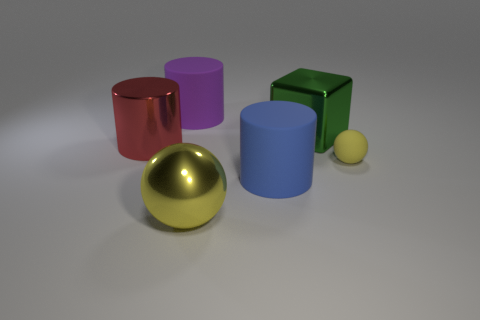Is the red cylinder made of the same material as the cylinder that is in front of the rubber ball?
Offer a very short reply. No. Do the tiny rubber thing and the large ball have the same color?
Provide a succinct answer. Yes. What is the size of the cylinder that is in front of the metal object to the left of the purple matte cylinder?
Offer a very short reply. Large. The small yellow thing has what shape?
Your answer should be compact. Sphere. There is a sphere that is in front of the small rubber thing; what is it made of?
Give a very brief answer. Metal. There is a sphere on the left side of the rubber cylinder that is right of the large shiny ball in front of the large blue rubber cylinder; what is its color?
Give a very brief answer. Yellow. There is a shiny sphere that is the same size as the green metallic cube; what is its color?
Provide a short and direct response. Yellow. What number of shiny things are tiny red cylinders or tiny yellow things?
Ensure brevity in your answer.  0. There is a big cylinder that is made of the same material as the green object; what is its color?
Make the answer very short. Red. What material is the large cylinder in front of the sphere that is behind the large yellow metal sphere made of?
Make the answer very short. Rubber. 